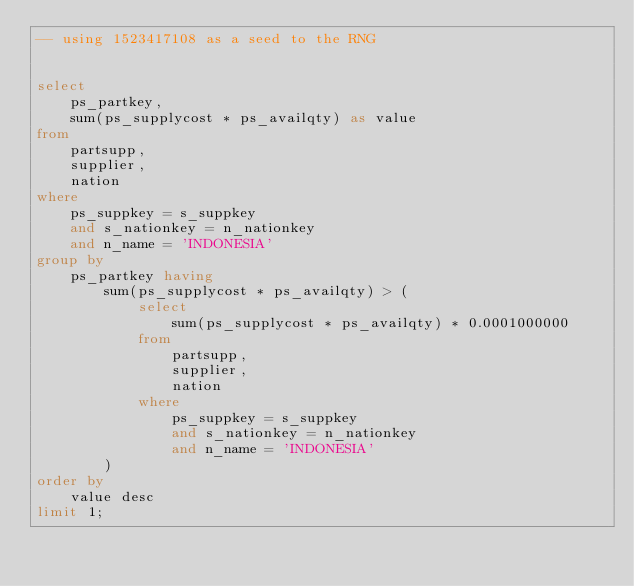<code> <loc_0><loc_0><loc_500><loc_500><_SQL_>-- using 1523417108 as a seed to the RNG


select
	ps_partkey,
	sum(ps_supplycost * ps_availqty) as value
from
	partsupp,
	supplier,
	nation
where
	ps_suppkey = s_suppkey
	and s_nationkey = n_nationkey
	and n_name = 'INDONESIA'
group by
	ps_partkey having
		sum(ps_supplycost * ps_availqty) > (
			select
				sum(ps_supplycost * ps_availqty) * 0.0001000000
			from
				partsupp,
				supplier,
				nation
			where
				ps_suppkey = s_suppkey
				and s_nationkey = n_nationkey
				and n_name = 'INDONESIA'
		)
order by
	value desc
limit 1;
</code> 